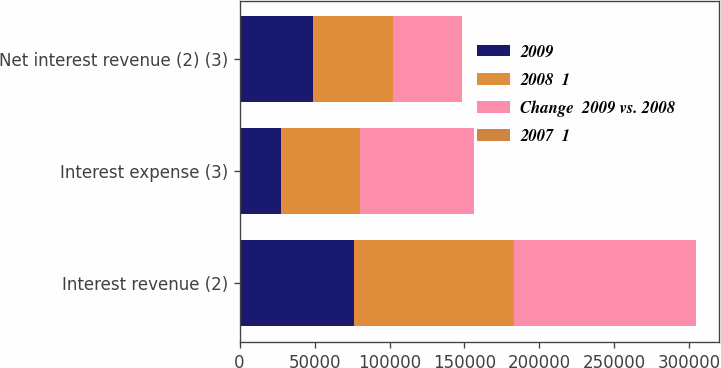Convert chart to OTSL. <chart><loc_0><loc_0><loc_500><loc_500><stacked_bar_chart><ecel><fcel>Interest revenue (2)<fcel>Interest expense (3)<fcel>Net interest revenue (2) (3)<nl><fcel>2009<fcel>76635<fcel>27721<fcel>48914<nl><fcel>2008  1<fcel>106499<fcel>52750<fcel>53749<nl><fcel>Change  2009 vs. 2008<fcel>121347<fcel>75958<fcel>45389<nl><fcel>2007  1<fcel>28<fcel>47<fcel>9<nl></chart> 